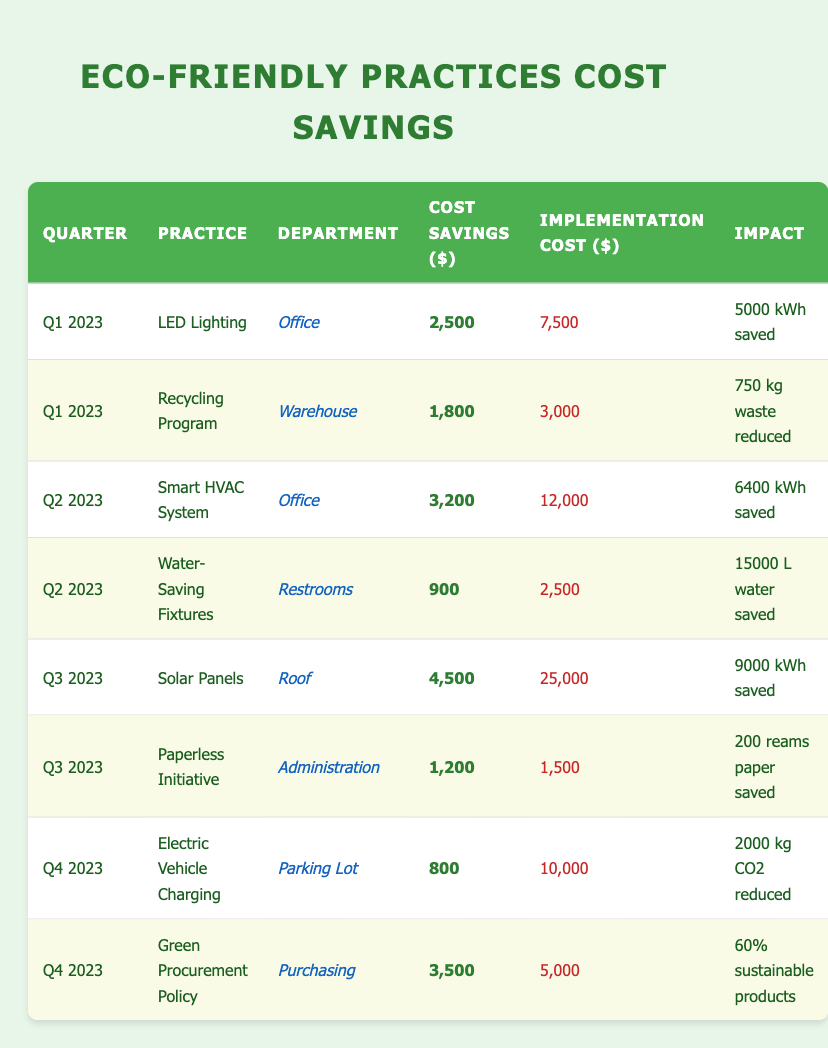What are the total cost savings from eco-friendly practices in Q1 2023? In Q1 2023, the cost savings are $2,500 from LED Lighting and $1,800 from the Recycling Program. Adding these amounts gives $2,500 + $1,800 = $4,300 as the total savings for that quarter.
Answer: 4,300 What practice had the highest implementation cost in Q2 2023? In Q2 2023, the Smart HVAC System had an implementation cost of $12,000, while the Water-Saving Fixtures had a cost of $2,500. Therefore, the Smart HVAC System has the highest implementation cost in that quarter.
Answer: Smart HVAC System Did the Solar Panels provide higher cost savings than the Paperless Initiative? Yes, the Solar Panels provided $4,500 in cost savings, while the Paperless Initiative provided $1,200. Comparing these values, $4,500 is greater than $1,200.
Answer: Yes What is the average cost savings per eco-friendly practice implemented in Q3 2023? In Q3 2023, the Solar Panels provided $4,500, and the Paperless Initiative contributed $1,200. Summing these amounts gives $4,500 + $1,200 = $5,700. Dividing this total by 2 (as there are 2 practices in Q3) results in an average cost savings of $5,700 / 2 = $2,850.
Answer: 2,850 Which department implemented the practice that saved the least amount of money in Q4 2023? In Q4 2023, the Electric Vehicle Charging generated savings of $800, while the Green Procurement Policy saved $3,500. Since $800 is less than $3,500, the Electric Vehicle Charging is the practice with the least savings in that quarter, implemented by the Parking Lot department.
Answer: Parking Lot (Electric Vehicle Charging) What was the total cost savings from all eco-friendly practices implemented in 2023? To find the total savings for the entire year of 2023, we add all the cost savings: Q1 ($4,300) + Q2 ($4,100) + Q3 ($5,700) + Q4 ($4,300) = $18,400. Therefore, the total cost savings from all practices are $18,400.
Answer: 18,400 Is the cost savings from the Green Procurement Policy more than double the savings of the Electric Vehicle Charging practice? The Green Procurement Policy saved $3,500, while the Electric Vehicle Charging saved $800. To check if $3,500 is more than double $800, we calculate double the savings of Electric Vehicle Charging: $800 * 2 = $1,600. Since $3,500 is greater than $1,600, the answer is yes.
Answer: Yes What percentage of cost savings in Q3 2023 came from the Solar Panels? In Q3 2023, the total cost savings is $4,500 (Solar Panels) + $1,200 (Paperless Initiative) = $5,700. The savings from the Solar Panels as a percentage of the total is ($4,500 / $5,700) * 100 = 78.95%. Thus, approximately 79% of the cost savings came from the Solar Panels.
Answer: 79% What was the impact of the Recycling Program in terms of waste reduction? The Recycling Program resulted in a waste reduction of 750 kg, which clearly states the environmental impact of implementing this eco-friendly practice.
Answer: 750 kg 